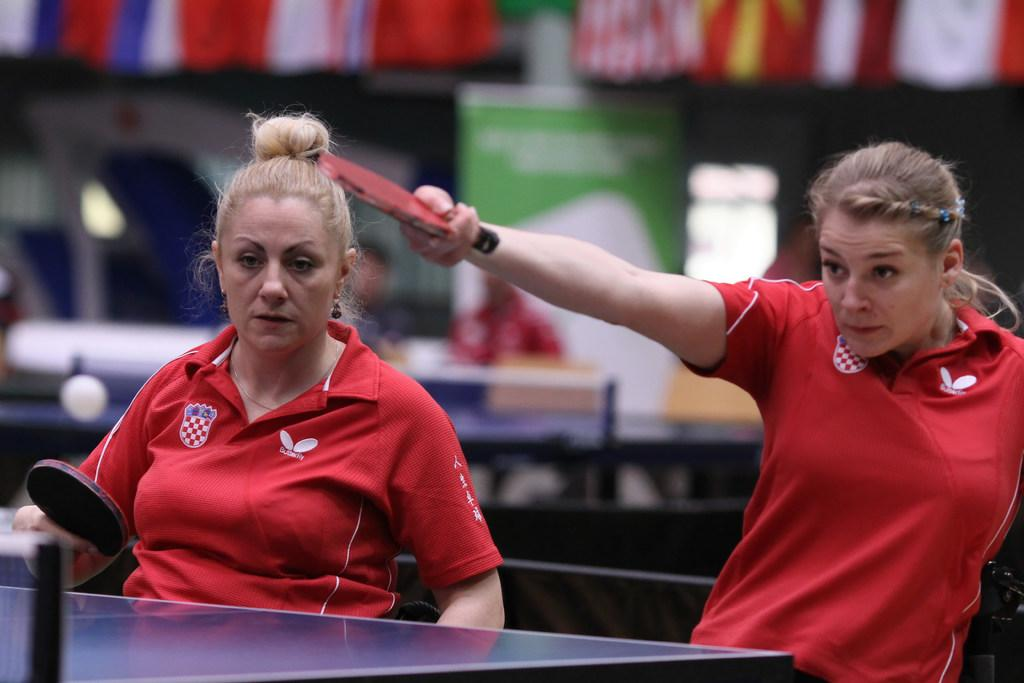How many people are in the image? There are two women in the image. What are the women holding in the image? The women are holding tennis bats. What object is present in the image that is related to tennis? There is a tennis table in the image. What type of acoustics can be heard coming from the tennis table in the image? There is no sound or acoustics present in the image, as it is a still photograph. 